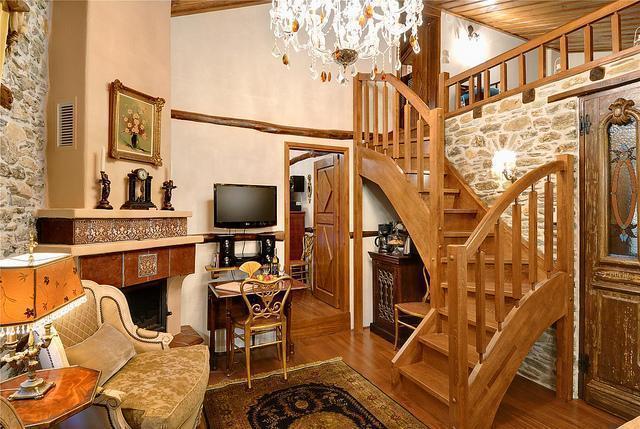What form of heating is used here?
Choose the right answer from the provided options to respond to the question.
Options: Steam, coal, gas, wood. Wood. 